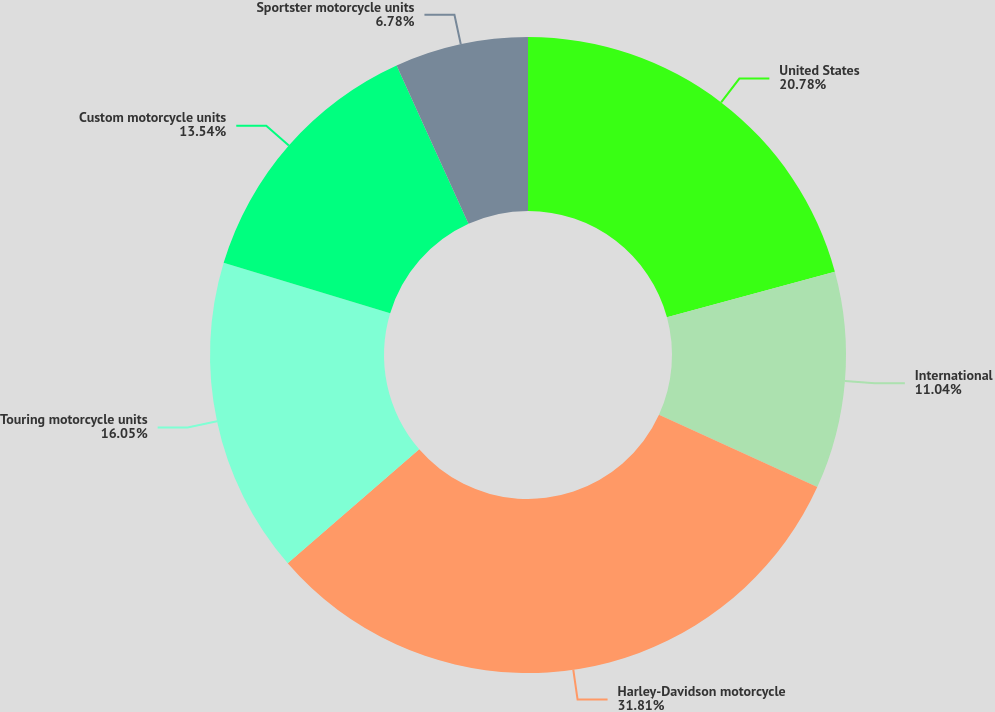Convert chart. <chart><loc_0><loc_0><loc_500><loc_500><pie_chart><fcel>United States<fcel>International<fcel>Harley-Davidson motorcycle<fcel>Touring motorcycle units<fcel>Custom motorcycle units<fcel>Sportster motorcycle units<nl><fcel>20.78%<fcel>11.04%<fcel>31.82%<fcel>16.05%<fcel>13.54%<fcel>6.78%<nl></chart> 